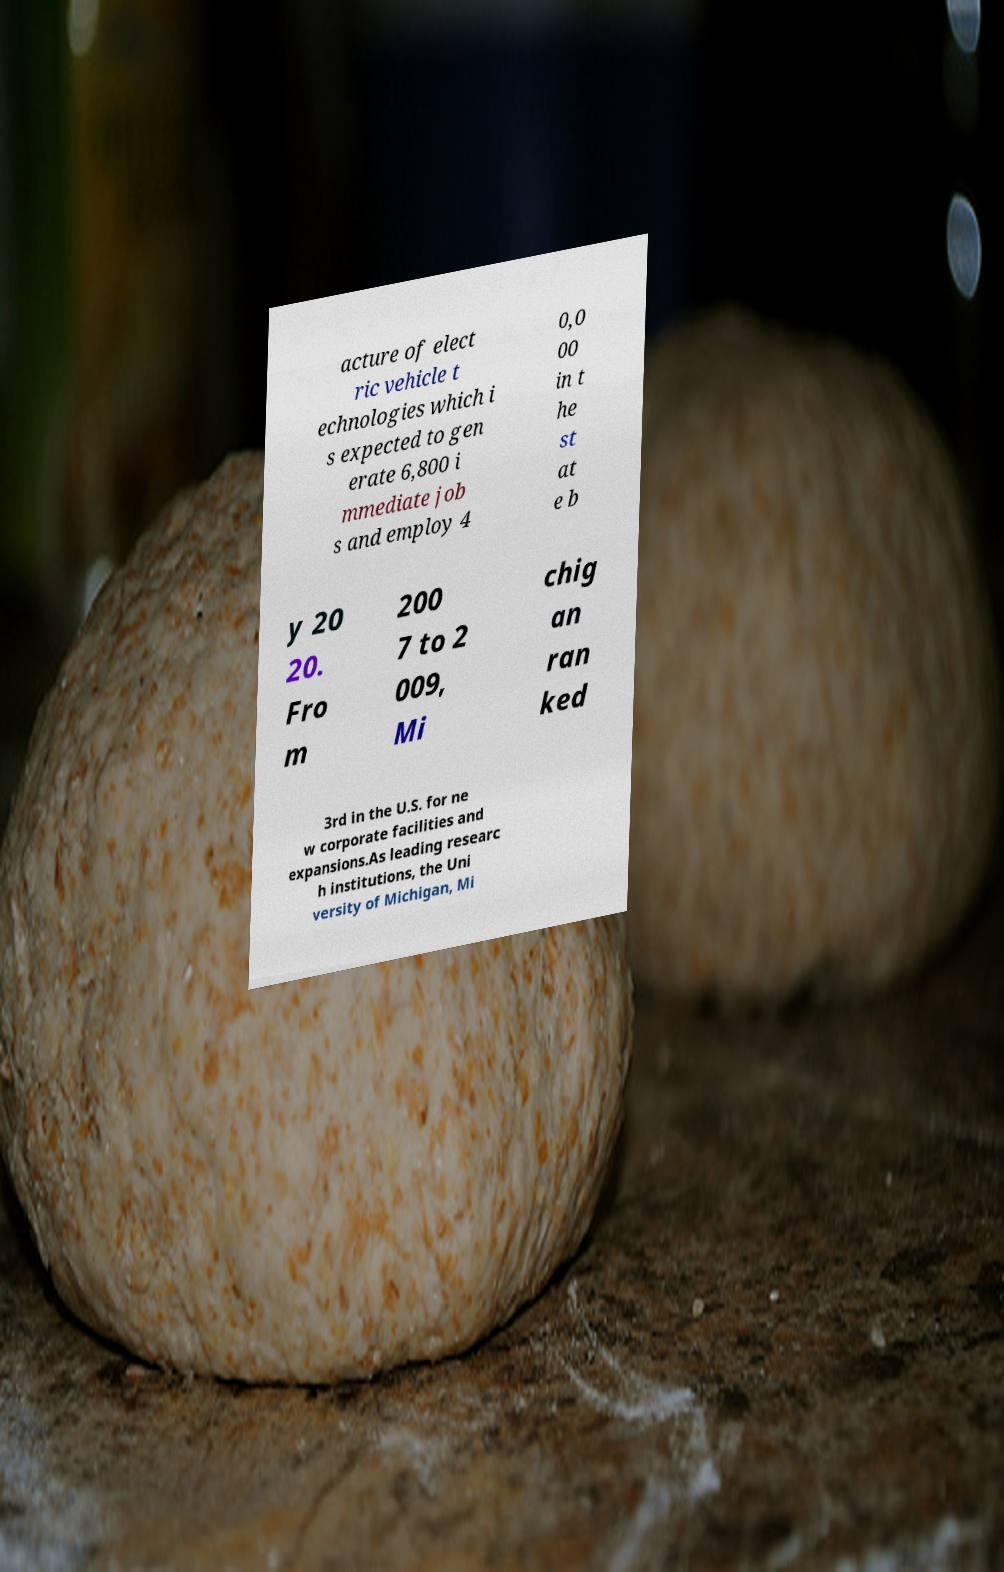For documentation purposes, I need the text within this image transcribed. Could you provide that? acture of elect ric vehicle t echnologies which i s expected to gen erate 6,800 i mmediate job s and employ 4 0,0 00 in t he st at e b y 20 20. Fro m 200 7 to 2 009, Mi chig an ran ked 3rd in the U.S. for ne w corporate facilities and expansions.As leading researc h institutions, the Uni versity of Michigan, Mi 